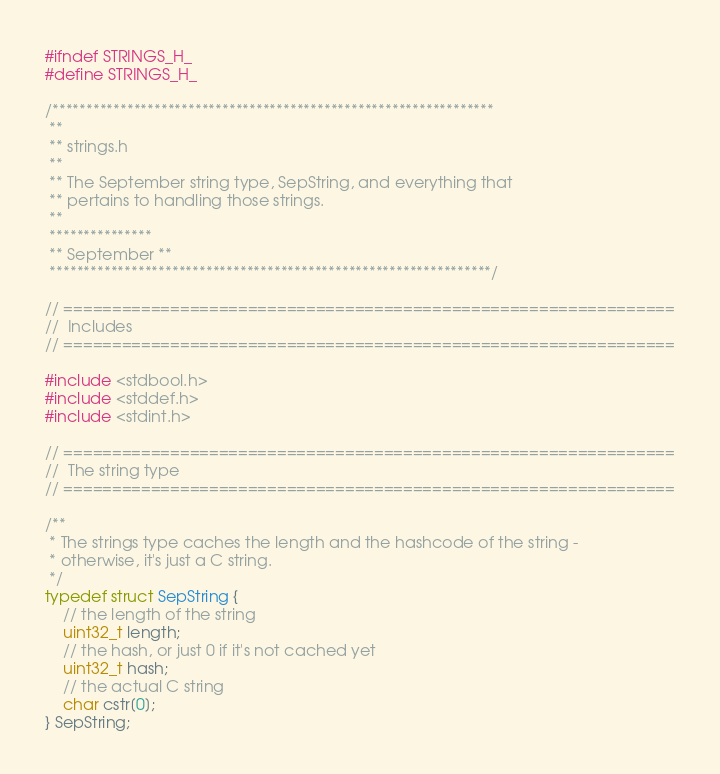Convert code to text. <code><loc_0><loc_0><loc_500><loc_500><_C_>#ifndef STRINGS_H_
#define STRINGS_H_

/*****************************************************************
 **
 ** strings.h
 **
 ** The September string type, SepString, and everything that
 ** pertains to handling those strings.
 **
 ***************
 ** September **
 *****************************************************************/

// ===============================================================
//  Includes
// ===============================================================

#include <stdbool.h>
#include <stddef.h>
#include <stdint.h>

// ===============================================================
//  The string type
// ===============================================================

/**
 * The strings type caches the length and the hashcode of the string -
 * otherwise, it's just a C string.
 */
typedef struct SepString {
	// the length of the string
	uint32_t length;
	// the hash, or just 0 if it's not cached yet
	uint32_t hash;
	// the actual C string
	char cstr[0];
} SepString;
</code> 